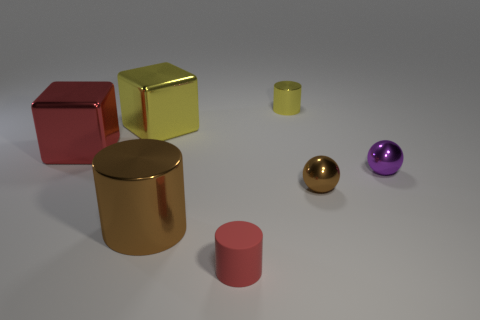Subtract all brown cylinders. How many cylinders are left? 2 Subtract all tiny metallic cylinders. How many cylinders are left? 2 Subtract 0 cyan cylinders. How many objects are left? 7 Subtract all balls. How many objects are left? 5 Subtract 1 cubes. How many cubes are left? 1 Subtract all brown cylinders. Subtract all purple balls. How many cylinders are left? 2 Subtract all cyan balls. How many green cylinders are left? 0 Subtract all tiny cyan cylinders. Subtract all brown metallic balls. How many objects are left? 6 Add 7 purple objects. How many purple objects are left? 8 Add 7 tiny purple things. How many tiny purple things exist? 8 